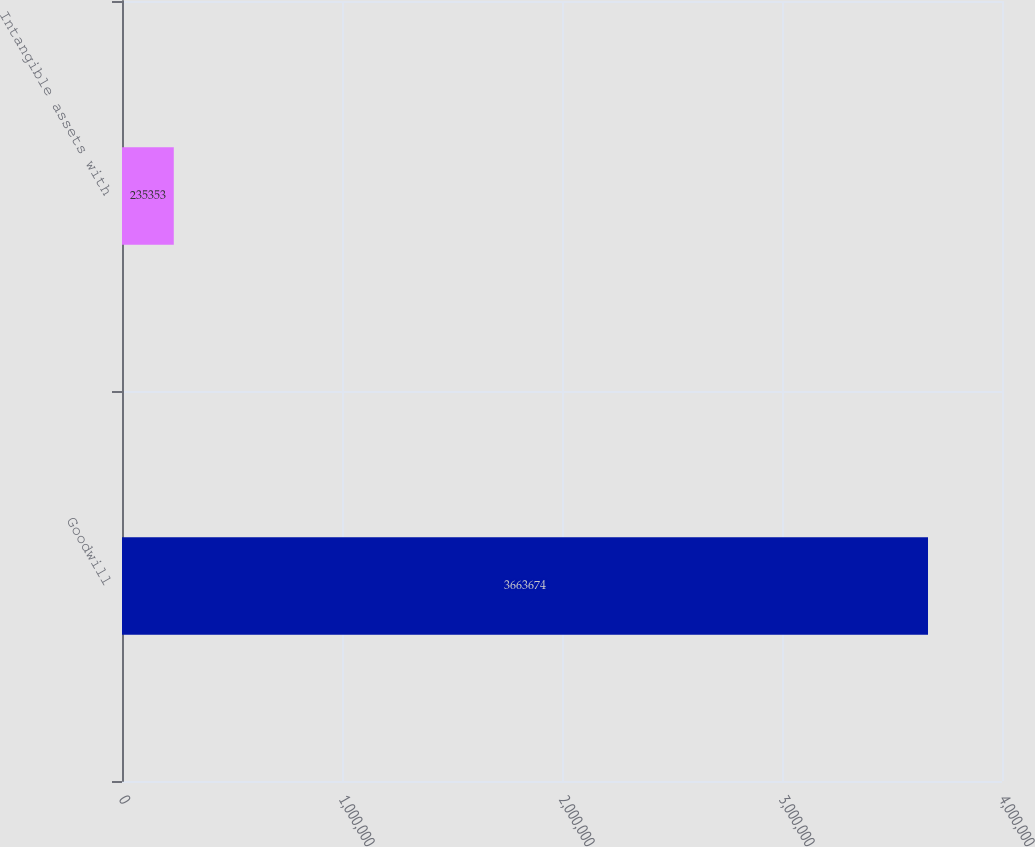<chart> <loc_0><loc_0><loc_500><loc_500><bar_chart><fcel>Goodwill<fcel>Intangible assets with<nl><fcel>3.66367e+06<fcel>235353<nl></chart> 